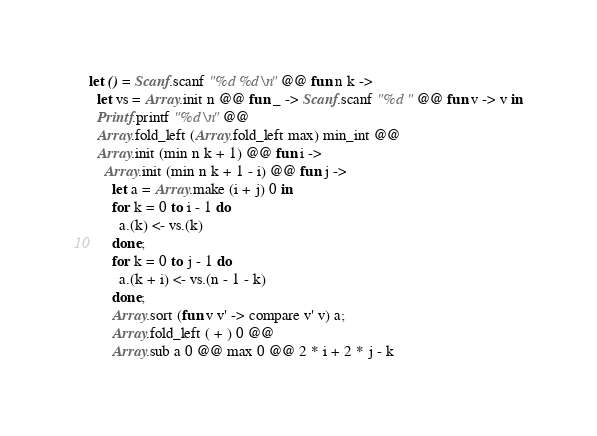<code> <loc_0><loc_0><loc_500><loc_500><_OCaml_>let () = Scanf.scanf "%d %d\n" @@ fun n k ->
  let vs = Array.init n @@ fun _ -> Scanf.scanf "%d " @@ fun v -> v in
  Printf.printf "%d\n" @@
  Array.fold_left (Array.fold_left max) min_int @@
  Array.init (min n k + 1) @@ fun i ->
    Array.init (min n k + 1 - i) @@ fun j ->
      let a = Array.make (i + j) 0 in
      for k = 0 to i - 1 do
        a.(k) <- vs.(k)
      done;
      for k = 0 to j - 1 do
        a.(k + i) <- vs.(n - 1 - k)
      done;
      Array.sort (fun v v' -> compare v' v) a;
      Array.fold_left ( + ) 0 @@
      Array.sub a 0 @@ max 0 @@ 2 * i + 2 * j - k</code> 